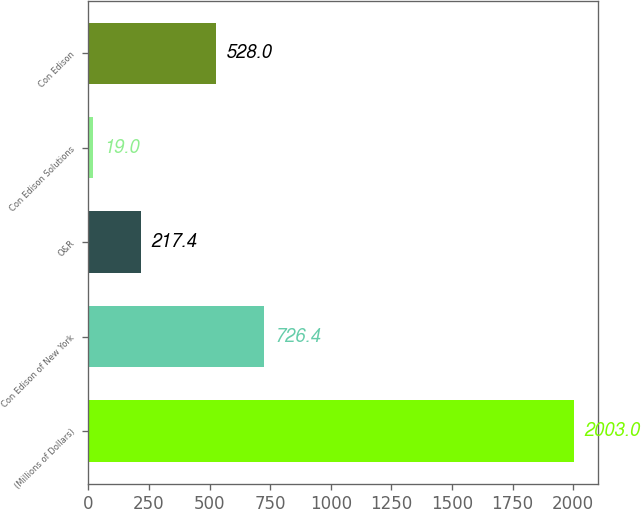Convert chart to OTSL. <chart><loc_0><loc_0><loc_500><loc_500><bar_chart><fcel>(Millions of Dollars)<fcel>Con Edison of New York<fcel>O&R<fcel>Con Edison Solutions<fcel>Con Edison<nl><fcel>2003<fcel>726.4<fcel>217.4<fcel>19<fcel>528<nl></chart> 